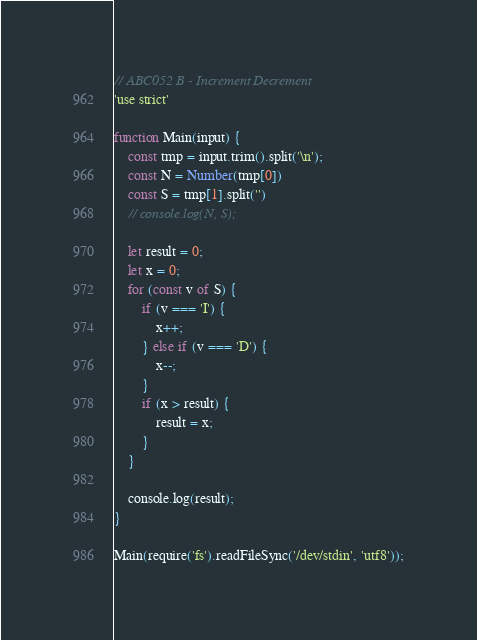Convert code to text. <code><loc_0><loc_0><loc_500><loc_500><_JavaScript_>// ABC052 B - Increment Decrement
'use strict'

function Main(input) {
    const tmp = input.trim().split('\n');
    const N = Number(tmp[0])
    const S = tmp[1].split('')
    // console.log(N, S);

    let result = 0;
    let x = 0;
    for (const v of S) {
        if (v === 'I') {
            x++;
        } else if (v === 'D') {
            x--;
        }
        if (x > result) {
            result = x;
        }
    }
    
    console.log(result);
}

Main(require('fs').readFileSync('/dev/stdin', 'utf8'));</code> 